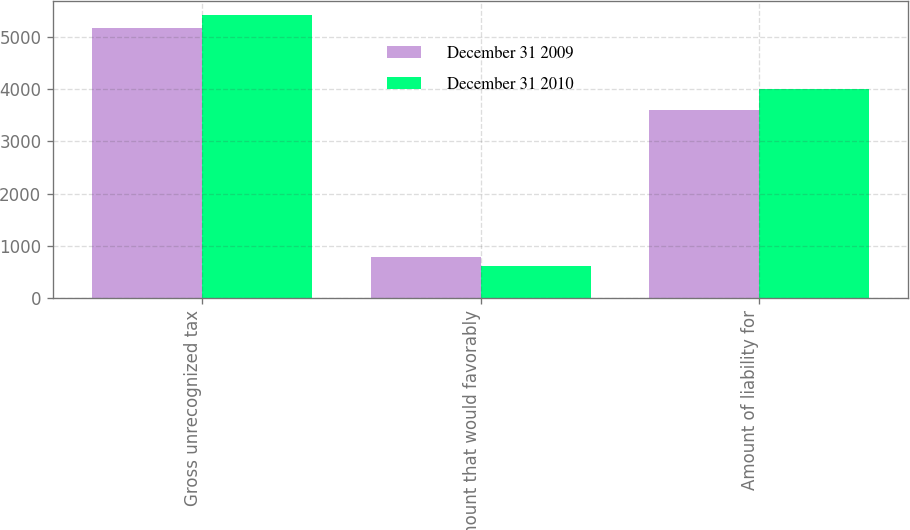Convert chart. <chart><loc_0><loc_0><loc_500><loc_500><stacked_bar_chart><ecel><fcel>Gross unrecognized tax<fcel>Amount that would favorably<fcel>Amount of liability for<nl><fcel>December 31 2009<fcel>5169<fcel>785<fcel>3605<nl><fcel>December 31 2010<fcel>5410<fcel>618<fcel>4007<nl></chart> 